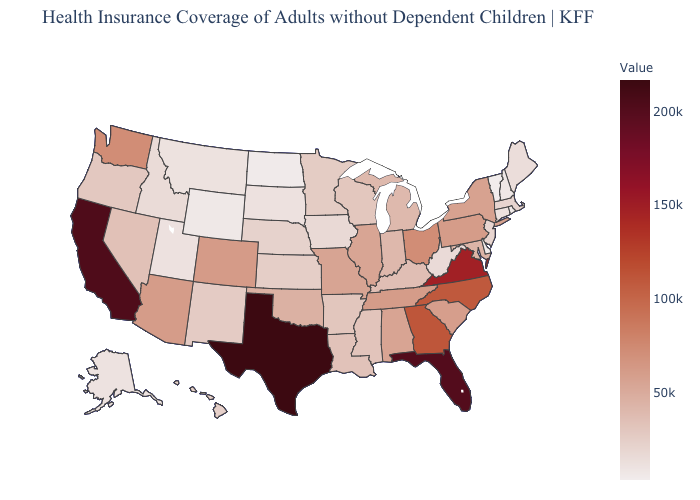Which states have the lowest value in the MidWest?
Quick response, please. North Dakota. Is the legend a continuous bar?
Give a very brief answer. Yes. Which states have the highest value in the USA?
Short answer required. Texas. Which states have the lowest value in the USA?
Answer briefly. Vermont. Which states have the lowest value in the MidWest?
Give a very brief answer. North Dakota. Does the map have missing data?
Answer briefly. No. Among the states that border New York , does Pennsylvania have the highest value?
Concise answer only. Yes. 